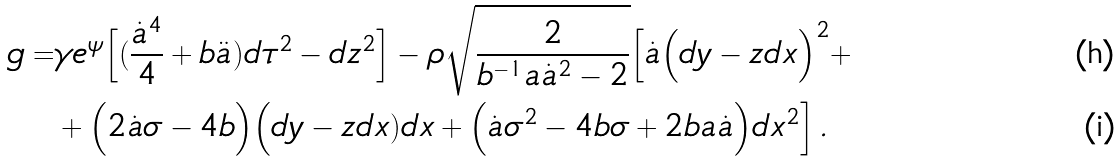<formula> <loc_0><loc_0><loc_500><loc_500>g = & \gamma e ^ { \psi } \Big [ ( \frac { \dot { a } ^ { 4 } } { 4 } + b \ddot { a } ) d \tau ^ { 2 } - d z ^ { 2 } \Big ] - \rho \sqrt { \frac { 2 } { b ^ { - 1 } a \dot { a } ^ { 2 } - 2 } } \Big [ \dot { a } \Big ( d y - z d x \Big ) ^ { 2 } + \\ & + \Big ( 2 \dot { a } \sigma - 4 b \Big ) \Big ( d y - z d x ) d x + \Big ( \dot { a } \sigma ^ { 2 } - 4 b \sigma + 2 b a \dot { a } \Big ) d x ^ { 2 } \Big ] \, .</formula> 